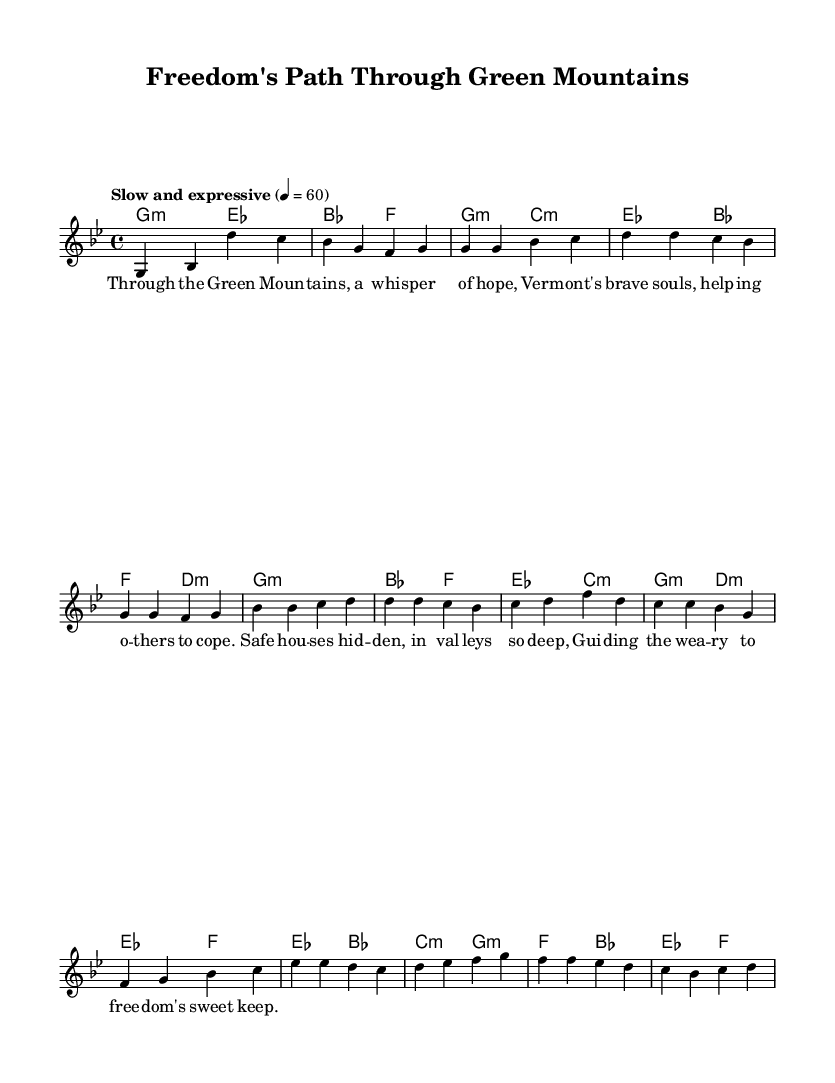What is the key signature of this music? The key signature is indicated by the number of sharps or flats placed after the clef. This piece is written in G minor, which has two flats (B♭ and E♭) indicated in the key signature.
Answer: G minor What is the time signature of the song? The time signature is represented by the numbers at the start of the piece, which indicate how many beats are in each measure. This piece has a time signature of 4/4, meaning there are four beats per measure.
Answer: 4/4 What is the tempo marking for this score? The tempo marking is specified in the score to instruct the speed of the piece. It states "Slow and expressive" at a quarter note = 60 beats per minute.
Answer: Slow and expressive How many verses are there in the music? By analyzing the structure of the piece, the text portion indicates that there is one stanza labeled as "Verse" with specified lyrics below it, implying only one verse.
Answer: 1 Which chord is used at the start of the chorus? The chords are indicated above the melody line; the chorus begins with a B♭ major chord, which is specified in the chord section associated with the chorus.
Answer: B♭ What is the main theme reflected in the lyrics? The lyrics describe the journey of helping others escape to freedom through the mountains, reflecting a message of hope and assistance during the Underground Railroad. This is evident from the repetitive themes in the text.
Answer: Freedom What musical elements are characteristic of this Soulful storytelling genre? Soul music typically emphasizes emotional expression and storytelling through lyrics. This score showcases this through its slow tempo, expressive phrasing, and a narrative focus on the historical significance of Vermont in the Underground Railroad.
Answer: Emotional expression 